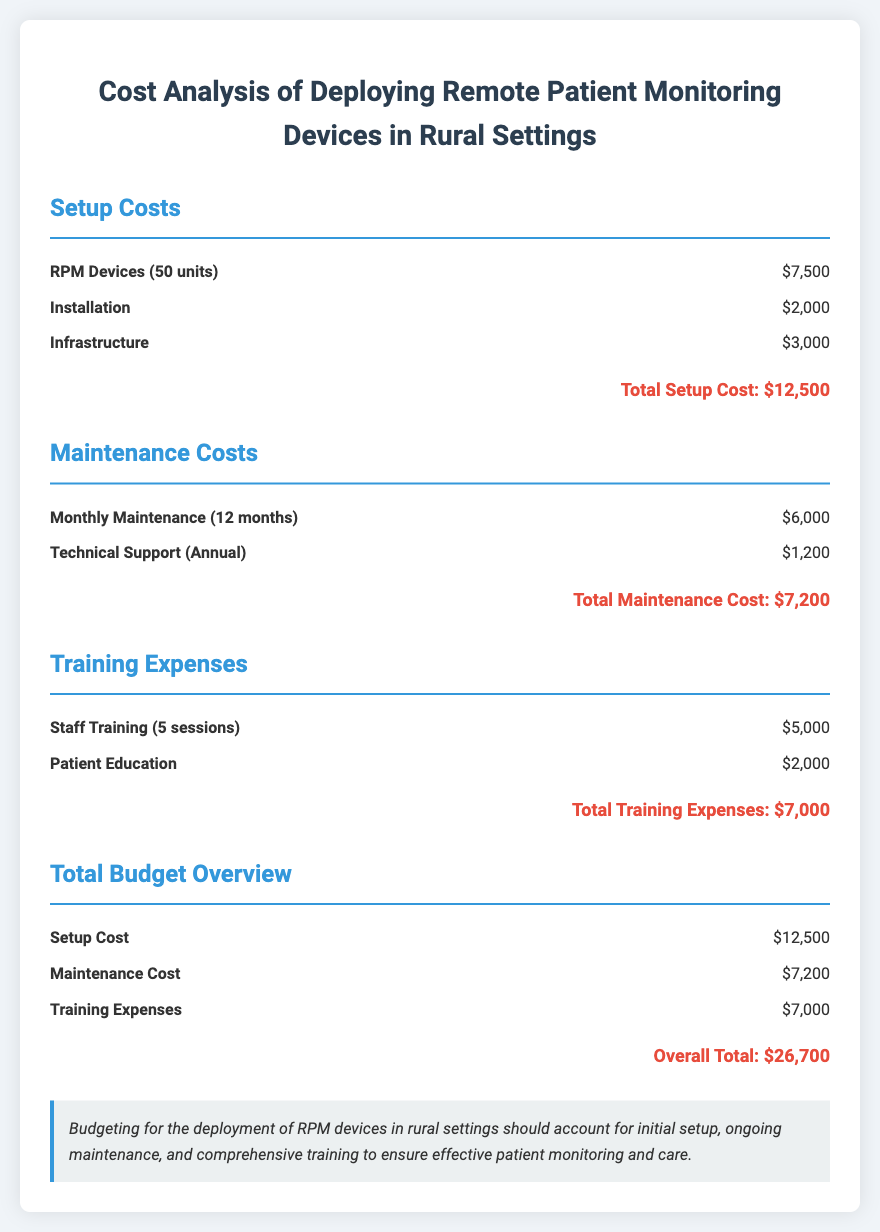what is the total setup cost? The total setup cost is listed under the Setup Costs section, which sums the costs of RPM devices, installation, and infrastructure.
Answer: $12,500 how many RPM devices are included in the setup? The document specifies that 50 units of RPM devices are included in the setup costs.
Answer: 50 units what is the cost for technical support? The cost for technical support is specified in the Maintenance Costs section as an annual expense.
Answer: $1,200 what are the total training expenses? The total training expenses summarize the costs of staff training and patient education.
Answer: $7,000 what is the overall total budget for the deployment? The overall total budget is the sum of setup cost, maintenance cost, and training expenses, as indicated in the Total Budget Overview section.
Answer: $26,700 how many months of monthly maintenance are included? The monthly maintenance cost is calculated for a duration of 12 months as per the Maintenance Costs section.
Answer: 12 months what is the total cost for patient education? The cost for patient education is listed alone in the Training Expenses section.
Answer: $2,000 which cost category has the highest expense? The total budget breakdown helps identify which category has the highest cost by comparing the totals across setup, maintenance, and training.
Answer: Setup Costs 